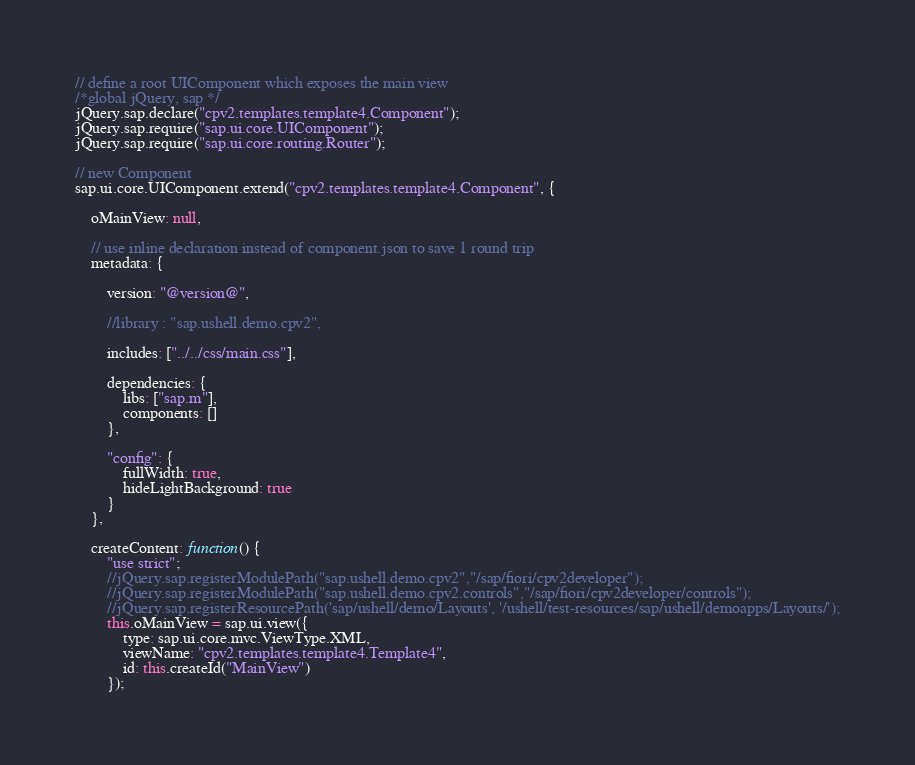Convert code to text. <code><loc_0><loc_0><loc_500><loc_500><_JavaScript_>// define a root UIComponent which exposes the main view
/*global jQuery, sap */
jQuery.sap.declare("cpv2.templates.template4.Component");
jQuery.sap.require("sap.ui.core.UIComponent");
jQuery.sap.require("sap.ui.core.routing.Router");

// new Component
sap.ui.core.UIComponent.extend("cpv2.templates.template4.Component", {

	oMainView: null,

	// use inline declaration instead of component.json to save 1 round trip
	metadata: {

		version: "@version@",

		//library : "sap.ushell.demo.cpv2",

		includes: ["../../css/main.css"],

		dependencies: {
			libs: ["sap.m"],
			components: []
		},

		"config": {
			fullWidth: true,
			hideLightBackground: true
		}
	},

	createContent: function() {
		"use strict";
		//jQuery.sap.registerModulePath("sap.ushell.demo.cpv2","/sap/fiori/cpv2developer");
		//jQuery.sap.registerModulePath("sap.ushell.demo.cpv2.controls","/sap/fiori/cpv2developer/controls");
		//jQuery.sap.registerResourcePath('sap/ushell/demo/Layouts', '/ushell/test-resources/sap/ushell/demoapps/Layouts/');
		this.oMainView = sap.ui.view({
			type: sap.ui.core.mvc.ViewType.XML,
			viewName: "cpv2.templates.template4.Template4",
			id: this.createId("MainView")
		});
</code> 